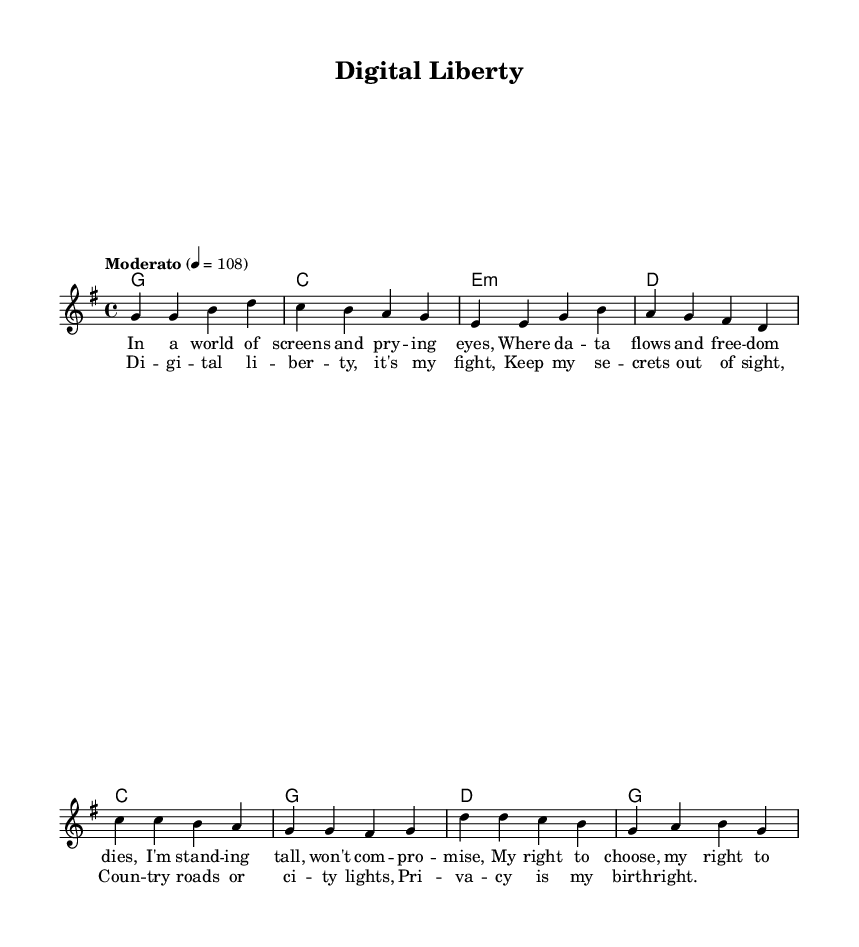What is the key signature of this music? The key signature indicated is G major, which has one sharp (F#). This can be identified from the initial key signature marking in the music notation.
Answer: G major What is the time signature of this piece? The time signature shown is 4/4, which means there are four beats in a measure and a quarter note gets one beat. This is a standard format verified by the time signature marking in the score.
Answer: 4/4 What is the tempo marking for the song? The tempo marking reads "Moderato" at a metronome of 108 beats per minute, indicating a moderate pace for performance. This is clearly stated in the notation.
Answer: Moderato 4 = 108 How many measures are in the verse section? The verse section consists of four measures. This can be counted by observing the bar lines separating the musical phrases in the melody.
Answer: Four What is the main theme discussed in the chorus lyrics? The chorus emphasizes the theme of digital liberty and the right to privacy. This can be determined by analyzing the lyrical content presented in the chorus section of the music.
Answer: Digital liberty How does the chord progression in the verse change? The chord progression in the verse follows a pattern from G to C, then to E minor and D. This can be seen by tracking the harmonic structure indicated under the melody for each corresponding measure.
Answer: G, C, E minor, D What is the primary message conveyed in this song? The primary message highlights the fight for personal freedom and privacy in a digital world. This is interpreted from the themes expressed in both verses and chorus lyrics throughout the piece.
Answer: Personal freedom and privacy 